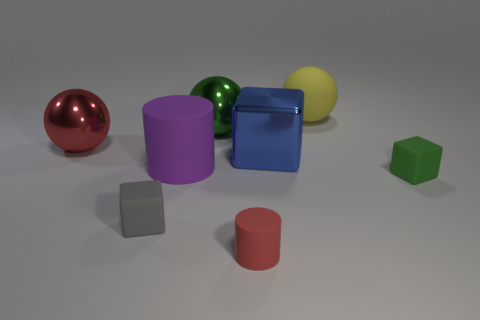Subtract all yellow rubber balls. How many balls are left? 2 Add 1 big green matte cubes. How many objects exist? 9 Subtract all blocks. How many objects are left? 5 Subtract 2 cylinders. How many cylinders are left? 0 Subtract all purple cylinders. How many cylinders are left? 1 Subtract all green cubes. How many yellow balls are left? 1 Subtract all metallic cubes. Subtract all gray matte things. How many objects are left? 6 Add 3 purple matte cylinders. How many purple matte cylinders are left? 4 Add 3 gray blocks. How many gray blocks exist? 4 Subtract 0 red cubes. How many objects are left? 8 